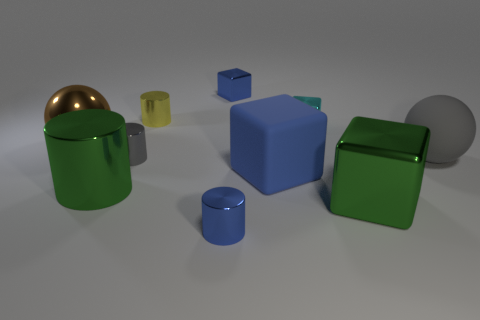What might be the purpose of arranging these objects in this manner? This arrangement looks like it could be part of a visual composition exercise, possibly for an art or design project. It demonstrates the concepts of balance, color contrast, and spatial distribution. Each object's placement could also serve to illustrate the principles of perspective and depth within a three-dimensional space. 